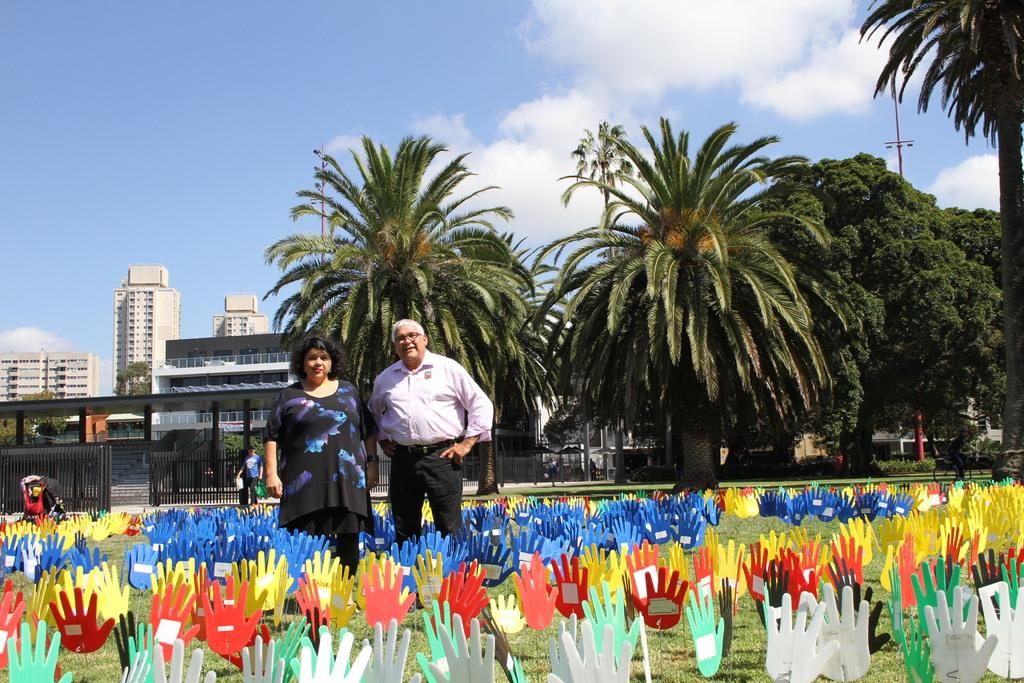How many people are present in the image? There are two people, a man and a woman, present in the image. What are the man and woman doing in the image? Both the man and woman are standing on the grass. What can be seen in the background of the image? There are buildings, trees, plants, gates, and the sky visible in the background of the image. What is the condition of the sky in the image? The sky is visible in the background of the image, and there are clouds present. What position does the man hold in the line in the image? There is no line present in the image, so it is not possible to determine the man's position in a line. 